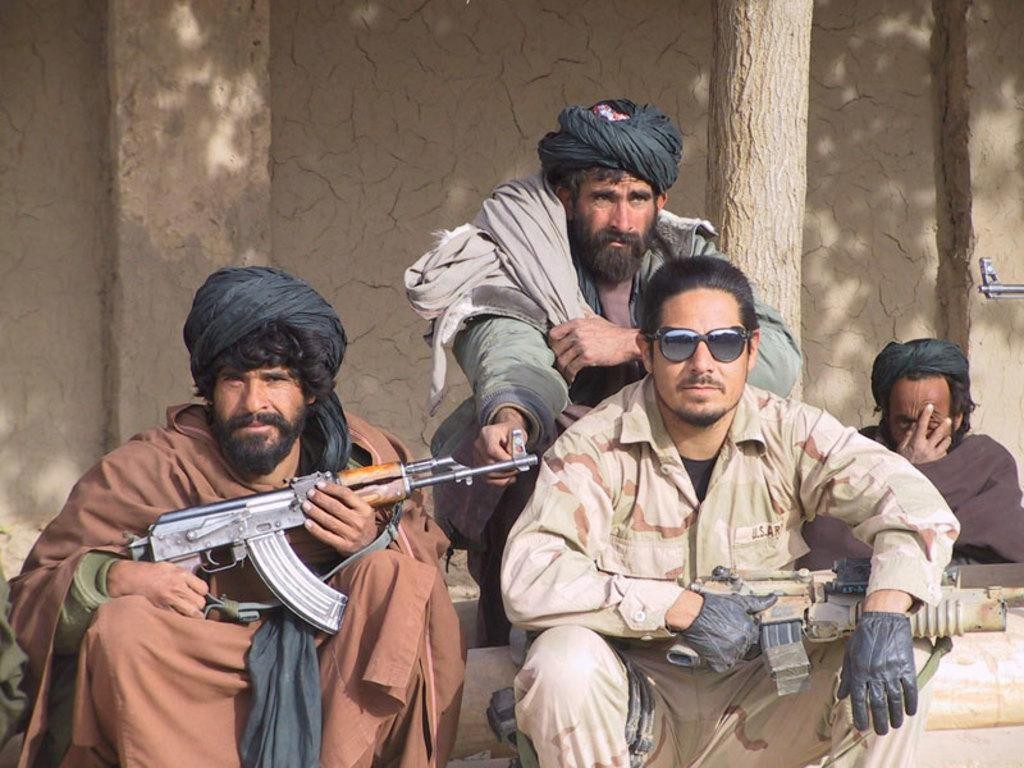How many people are in the image? There are people in the image. What are two people doing in the image? Two people are holding guns. How can you differentiate the dresses of the people in the image? The people are wearing different color dresses. What natural element can be seen in the image? There is a branch visible in the image. What is the color of the wall in the image? There is a brown color wall in the image. Where is the nest located in the image? There is no nest present in the image. Can you describe the park in the image? There is no park present in the image. 